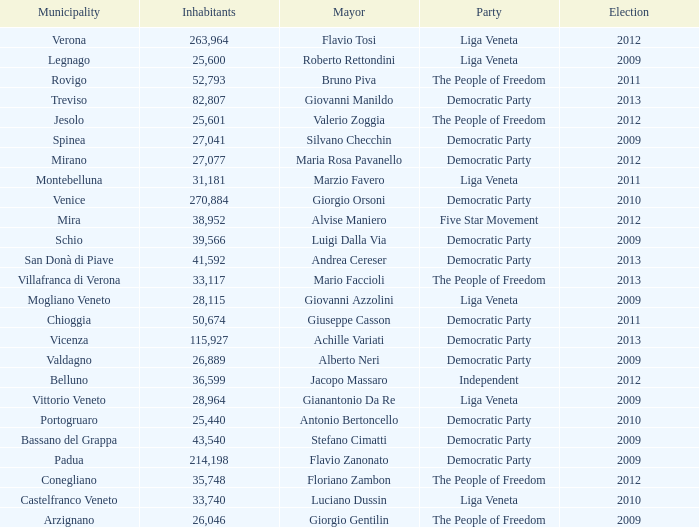How many Inhabitants were in the democratic party for an election before 2009 for Mayor of stefano cimatti? 0.0. 